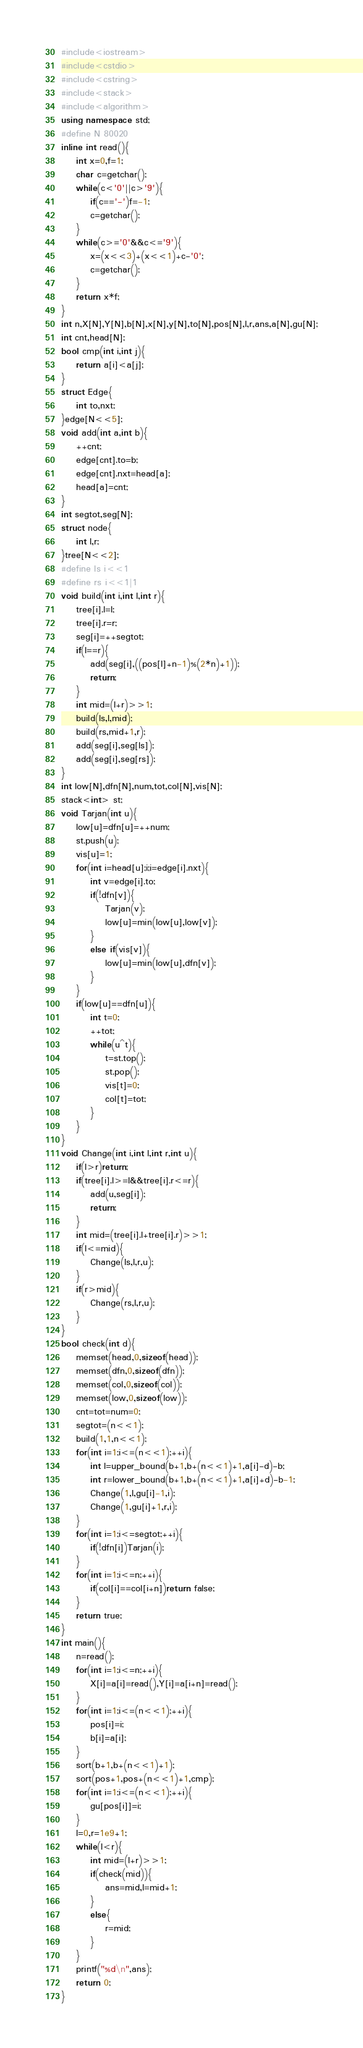Convert code to text. <code><loc_0><loc_0><loc_500><loc_500><_C++_>#include<iostream>
#include<cstdio>
#include<cstring>
#include<stack>
#include<algorithm>
using namespace std;
#define N 80020
inline int read(){
    int x=0,f=1;
    char c=getchar();
    while(c<'0'||c>'9'){
        if(c=='-')f=-1;
        c=getchar();
    }
    while(c>='0'&&c<='9'){
        x=(x<<3)+(x<<1)+c-'0';
        c=getchar();
    }
    return x*f;
}
int n,X[N],Y[N],b[N],x[N],y[N],to[N],pos[N],l,r,ans,a[N],gu[N];
int cnt,head[N];
bool cmp(int i,int j){
	return a[i]<a[j];
}
struct Edge{
	int to,nxt;
}edge[N<<5];
void add(int a,int b){
	++cnt;
	edge[cnt].to=b;
	edge[cnt].nxt=head[a];
	head[a]=cnt;
}
int segtot,seg[N];
struct node{
	int l,r;
}tree[N<<2];
#define ls i<<1
#define rs i<<1|1
void build(int i,int l,int r){
	tree[i].l=l;
	tree[i].r=r;
	seg[i]=++segtot;
	if(l==r){
		add(seg[i],((pos[l]+n-1)%(2*n)+1));
		return;
	}
	int mid=(l+r)>>1;
	build(ls,l,mid);
	build(rs,mid+1,r);
	add(seg[i],seg[ls]);
	add(seg[i],seg[rs]);
}
int low[N],dfn[N],num,tot,col[N],vis[N];
stack<int> st;
void Tarjan(int u){
	low[u]=dfn[u]=++num;
	st.push(u);
	vis[u]=1;
	for(int i=head[u];i;i=edge[i].nxt){
		int v=edge[i].to;
		if(!dfn[v]){
			Tarjan(v);
			low[u]=min(low[u],low[v]);
		}
		else if(vis[v]){
			low[u]=min(low[u],dfn[v]);
		}
	}
	if(low[u]==dfn[u]){
		int t=0;
		++tot;
		while(u^t){
			t=st.top();
			st.pop();
			vis[t]=0;
			col[t]=tot;
		}
	}
} 
void Change(int i,int l,int r,int u){
	if(l>r)return;
	if(tree[i].l>=l&&tree[i].r<=r){
		add(u,seg[i]);
		return;
	}
	int mid=(tree[i].l+tree[i].r)>>1;
	if(l<=mid){
		Change(ls,l,r,u);
	}
	if(r>mid){
		Change(rs,l,r,u);
	}
}
bool check(int d){
	memset(head,0,sizeof(head));
	memset(dfn,0,sizeof(dfn));
	memset(col,0,sizeof(col));
	memset(low,0,sizeof(low));
	cnt=tot=num=0;
	segtot=(n<<1);
	build(1,1,n<<1);
	for(int i=1;i<=(n<<1);++i){
		int l=upper_bound(b+1,b+(n<<1)+1,a[i]-d)-b;
		int r=lower_bound(b+1,b+(n<<1)+1,a[i]+d)-b-1;
		Change(1,l,gu[i]-1,i);
		Change(1,gu[i]+1,r,i);
	}
	for(int i=1;i<=segtot;++i){
		if(!dfn[i])Tarjan(i);
	}
	for(int i=1;i<=n;++i){
		if(col[i]==col[i+n])return false;
	}
	return true;
}
int main(){
	n=read();
	for(int i=1;i<=n;++i){
		X[i]=a[i]=read(),Y[i]=a[i+n]=read();
	}
	for(int i=1;i<=(n<<1);++i){
		pos[i]=i;
		b[i]=a[i];
	}
	sort(b+1,b+(n<<1)+1);
	sort(pos+1,pos+(n<<1)+1,cmp);
	for(int i=1;i<=(n<<1);++i){
		gu[pos[i]]=i;
	}
	l=0,r=1e9+1;
	while(l<r){
		int mid=(l+r)>>1;
		if(check(mid)){
			ans=mid,l=mid+1;
		}
		else{
			r=mid;
		}
	}
	printf("%d\n",ans);
	return 0;
}
</code> 